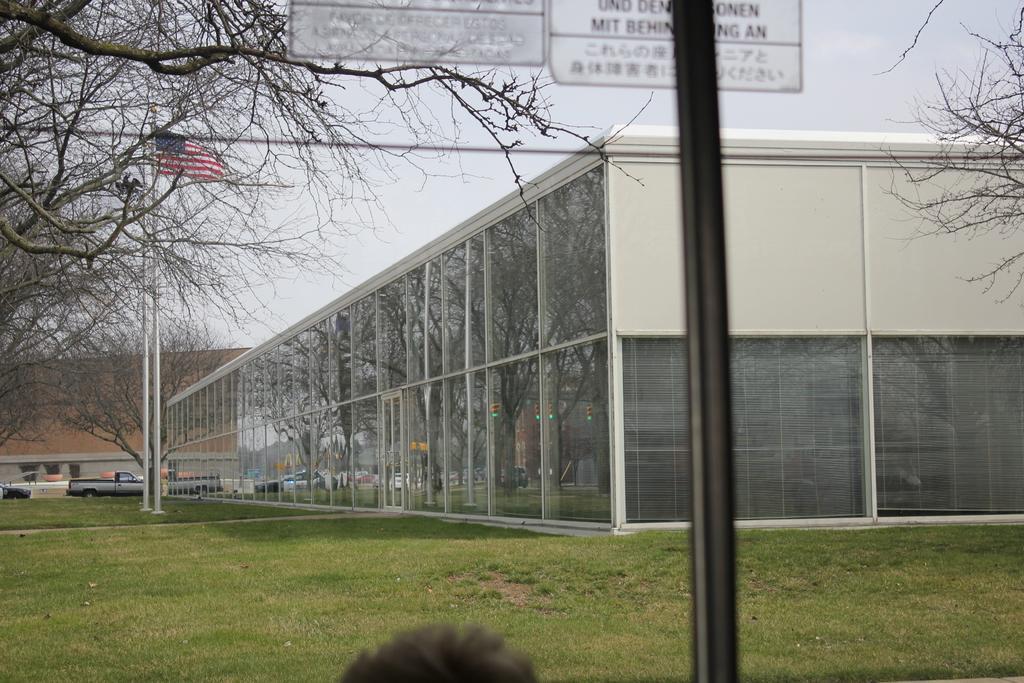Describe this image in one or two sentences. This is grass. There are poles, boards, flag, trees, vehicles, and buildings. In the background there is sky. 